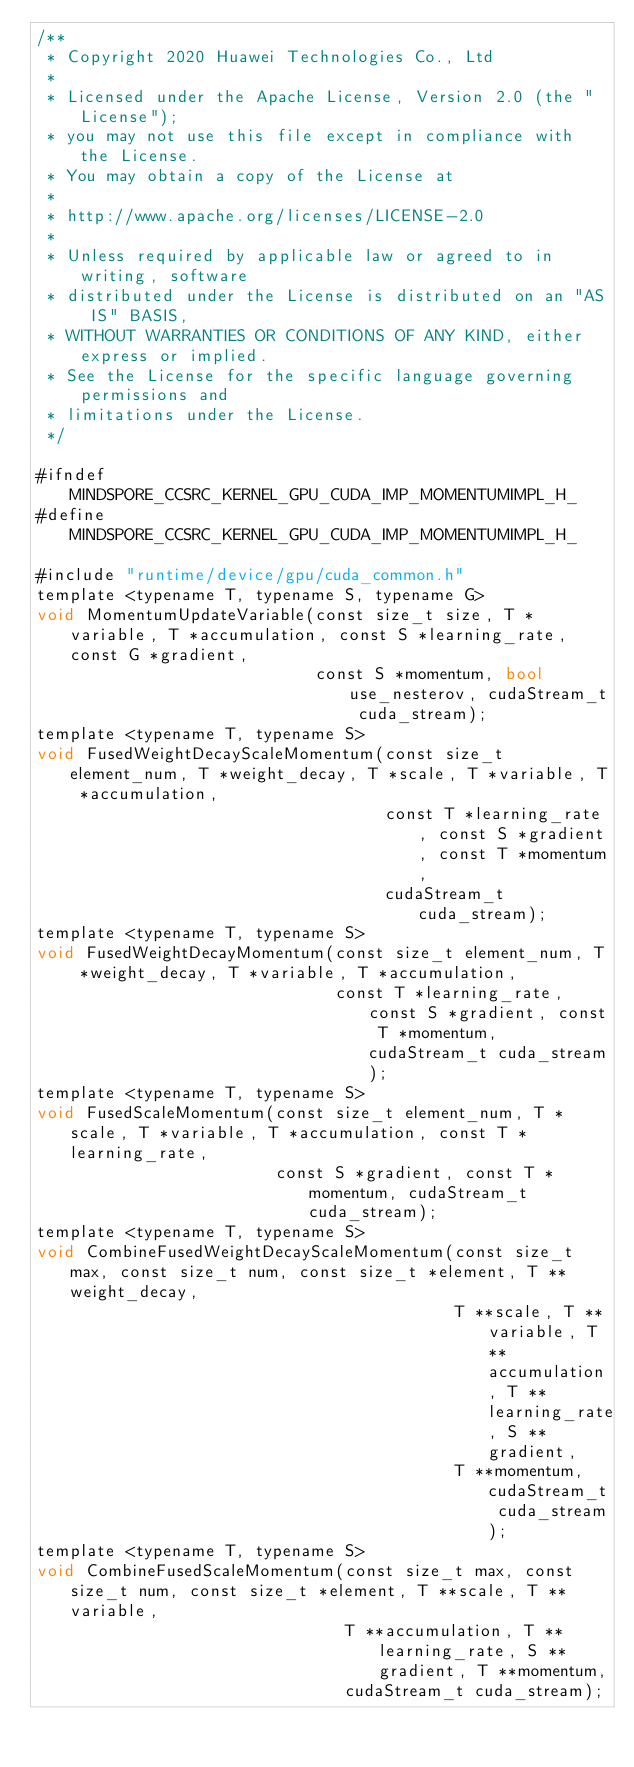Convert code to text. <code><loc_0><loc_0><loc_500><loc_500><_Cuda_>/**
 * Copyright 2020 Huawei Technologies Co., Ltd
 *
 * Licensed under the Apache License, Version 2.0 (the "License");
 * you may not use this file except in compliance with the License.
 * You may obtain a copy of the License at
 *
 * http://www.apache.org/licenses/LICENSE-2.0
 *
 * Unless required by applicable law or agreed to in writing, software
 * distributed under the License is distributed on an "AS IS" BASIS,
 * WITHOUT WARRANTIES OR CONDITIONS OF ANY KIND, either express or implied.
 * See the License for the specific language governing permissions and
 * limitations under the License.
 */

#ifndef MINDSPORE_CCSRC_KERNEL_GPU_CUDA_IMP_MOMENTUMIMPL_H_
#define MINDSPORE_CCSRC_KERNEL_GPU_CUDA_IMP_MOMENTUMIMPL_H_

#include "runtime/device/gpu/cuda_common.h"
template <typename T, typename S, typename G>
void MomentumUpdateVariable(const size_t size, T *variable, T *accumulation, const S *learning_rate, const G *gradient,
                            const S *momentum, bool use_nesterov, cudaStream_t cuda_stream);
template <typename T, typename S>
void FusedWeightDecayScaleMomentum(const size_t element_num, T *weight_decay, T *scale, T *variable, T *accumulation,
                                   const T *learning_rate, const S *gradient, const T *momentum,
                                   cudaStream_t cuda_stream);
template <typename T, typename S>
void FusedWeightDecayMomentum(const size_t element_num, T *weight_decay, T *variable, T *accumulation,
                              const T *learning_rate, const S *gradient, const T *momentum, cudaStream_t cuda_stream);
template <typename T, typename S>
void FusedScaleMomentum(const size_t element_num, T *scale, T *variable, T *accumulation, const T *learning_rate,
                        const S *gradient, const T *momentum, cudaStream_t cuda_stream);
template <typename T, typename S>
void CombineFusedWeightDecayScaleMomentum(const size_t max, const size_t num, const size_t *element, T **weight_decay,
                                          T **scale, T **variable, T **accumulation, T **learning_rate, S **gradient,
                                          T **momentum, cudaStream_t cuda_stream);
template <typename T, typename S>
void CombineFusedScaleMomentum(const size_t max, const size_t num, const size_t *element, T **scale, T **variable,
                               T **accumulation, T **learning_rate, S **gradient, T **momentum,
                               cudaStream_t cuda_stream);</code> 